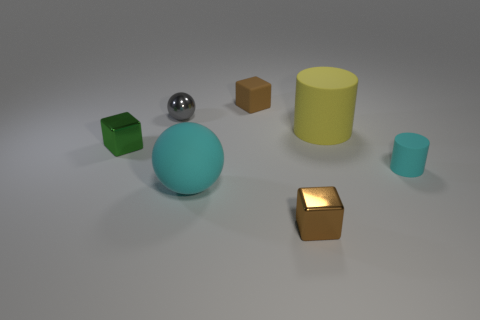There is a cyan thing that is to the left of the cyan rubber cylinder; does it have the same size as the yellow object?
Give a very brief answer. Yes. Is there a large blue matte sphere?
Your answer should be compact. No. How many things are either small metallic objects in front of the yellow cylinder or brown rubber blocks?
Offer a terse response. 3. There is a small metal sphere; is its color the same as the block that is on the left side of the small gray metal thing?
Make the answer very short. No. Are there any rubber cylinders of the same size as the cyan sphere?
Make the answer very short. Yes. What material is the cyan thing that is on the left side of the tiny brown block in front of the green cube made of?
Make the answer very short. Rubber. What number of small metallic blocks are the same color as the tiny matte cube?
Your answer should be compact. 1. There is a brown object that is made of the same material as the large cyan object; what is its shape?
Give a very brief answer. Cube. There is a brown object that is behind the tiny gray ball; what is its size?
Offer a very short reply. Small. Is the number of cyan rubber objects in front of the green object the same as the number of big cyan balls that are behind the small cyan matte thing?
Ensure brevity in your answer.  No. 